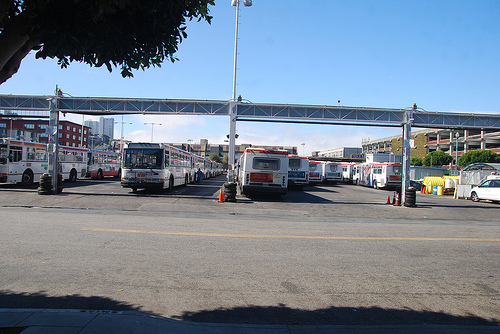How busy does this place seem, and how can you tell? The location seems moderately busy. The number of buses present suggests activity, but there's no visible movement of vehicles or people, which hints at a momentary lull or a break in operations. 